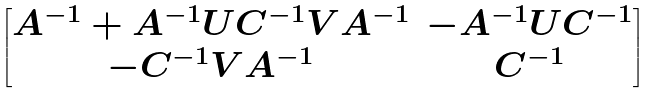<formula> <loc_0><loc_0><loc_500><loc_500>\begin{bmatrix} A ^ { - 1 } + A ^ { - 1 } U C ^ { - 1 } V A ^ { - 1 } & - A ^ { - 1 } U C ^ { - 1 } \\ - C ^ { - 1 } V A ^ { - 1 } & C ^ { - 1 } \end{bmatrix}</formula> 